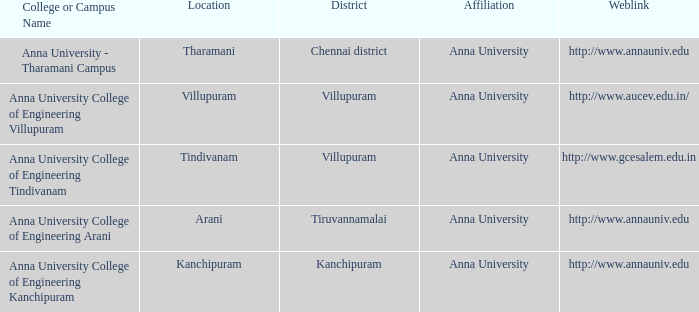In what area can a college or campus named anna university - tharamani campus be found? Tharamani. 